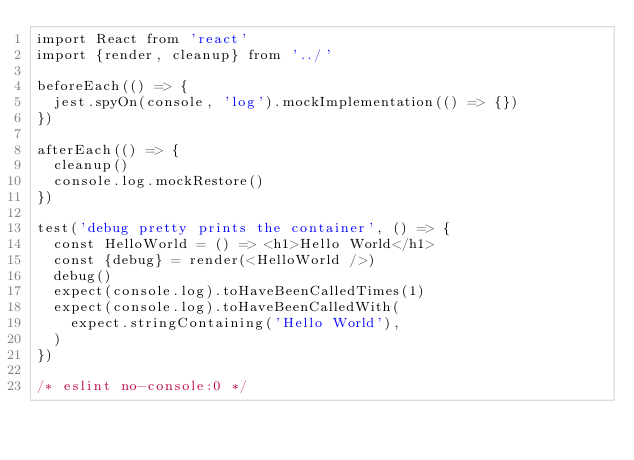Convert code to text. <code><loc_0><loc_0><loc_500><loc_500><_JavaScript_>import React from 'react'
import {render, cleanup} from '../'

beforeEach(() => {
  jest.spyOn(console, 'log').mockImplementation(() => {})
})

afterEach(() => {
  cleanup()
  console.log.mockRestore()
})

test('debug pretty prints the container', () => {
  const HelloWorld = () => <h1>Hello World</h1>
  const {debug} = render(<HelloWorld />)
  debug()
  expect(console.log).toHaveBeenCalledTimes(1)
  expect(console.log).toHaveBeenCalledWith(
    expect.stringContaining('Hello World'),
  )
})

/* eslint no-console:0 */
</code> 